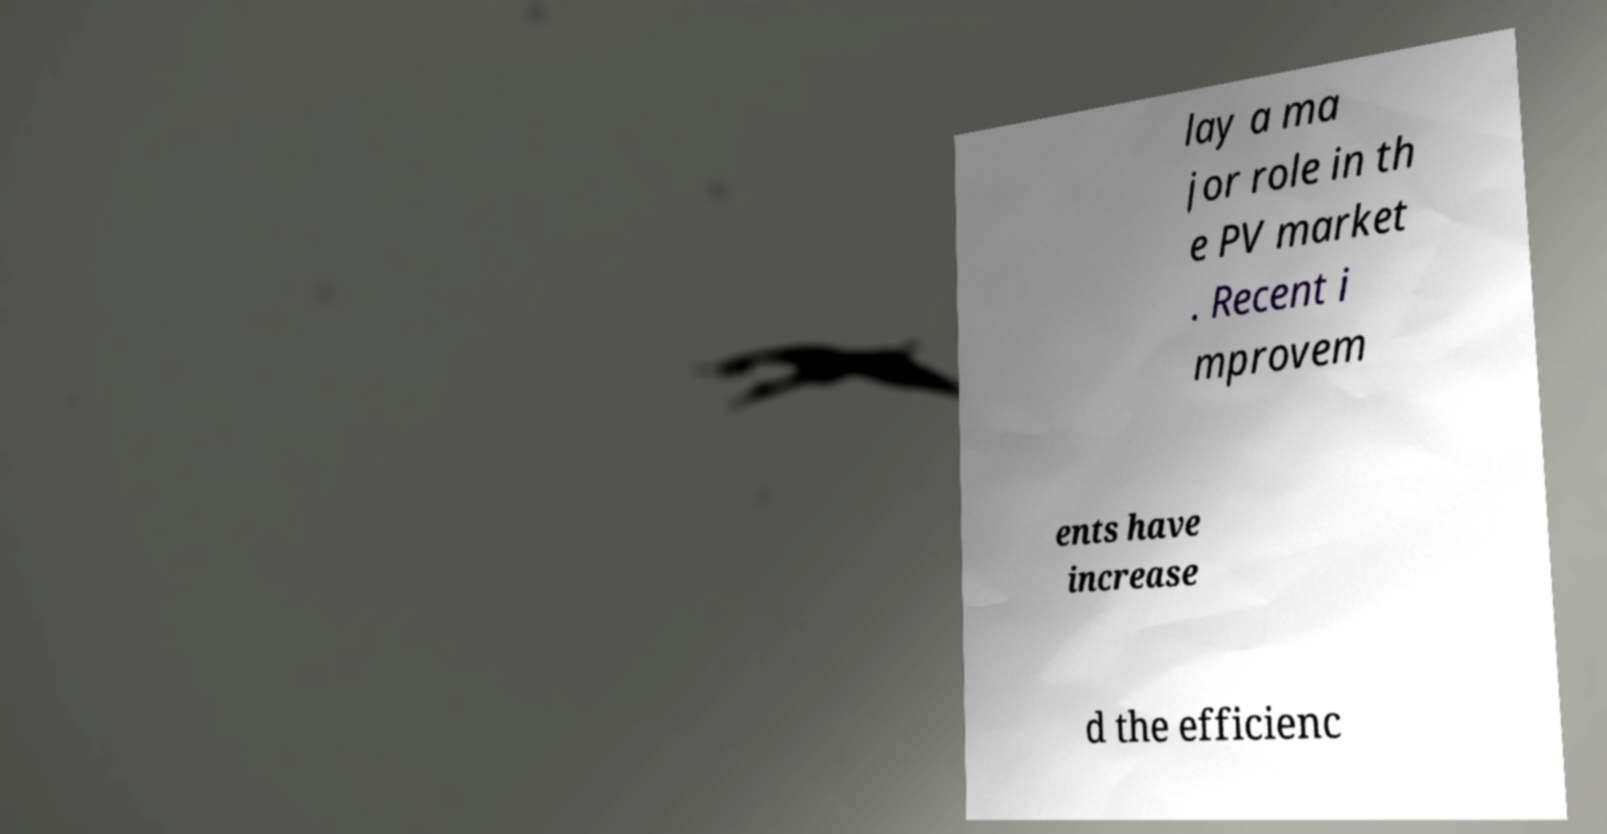I need the written content from this picture converted into text. Can you do that? lay a ma jor role in th e PV market . Recent i mprovem ents have increase d the efficienc 